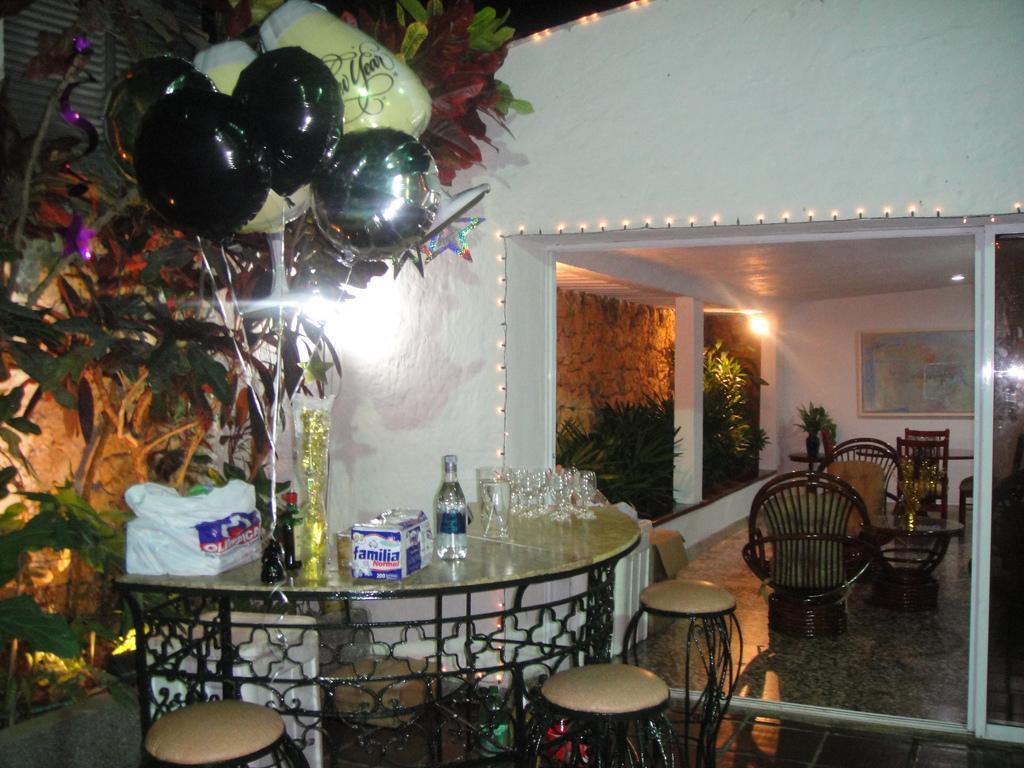How would you summarize this image in a sentence or two? This image is taken outdoors. In the middle of the image there is a table with a few things on it and there are three stools on the floor. On the left side of the image there are a few plants and there are a few balloons. There is a text on the balloon. On the right side of the image there is a room with a wall and a door and there are a few chairs in the room and there is a picture frame on the wall. There is a pillar, a light and there are a few plants. 